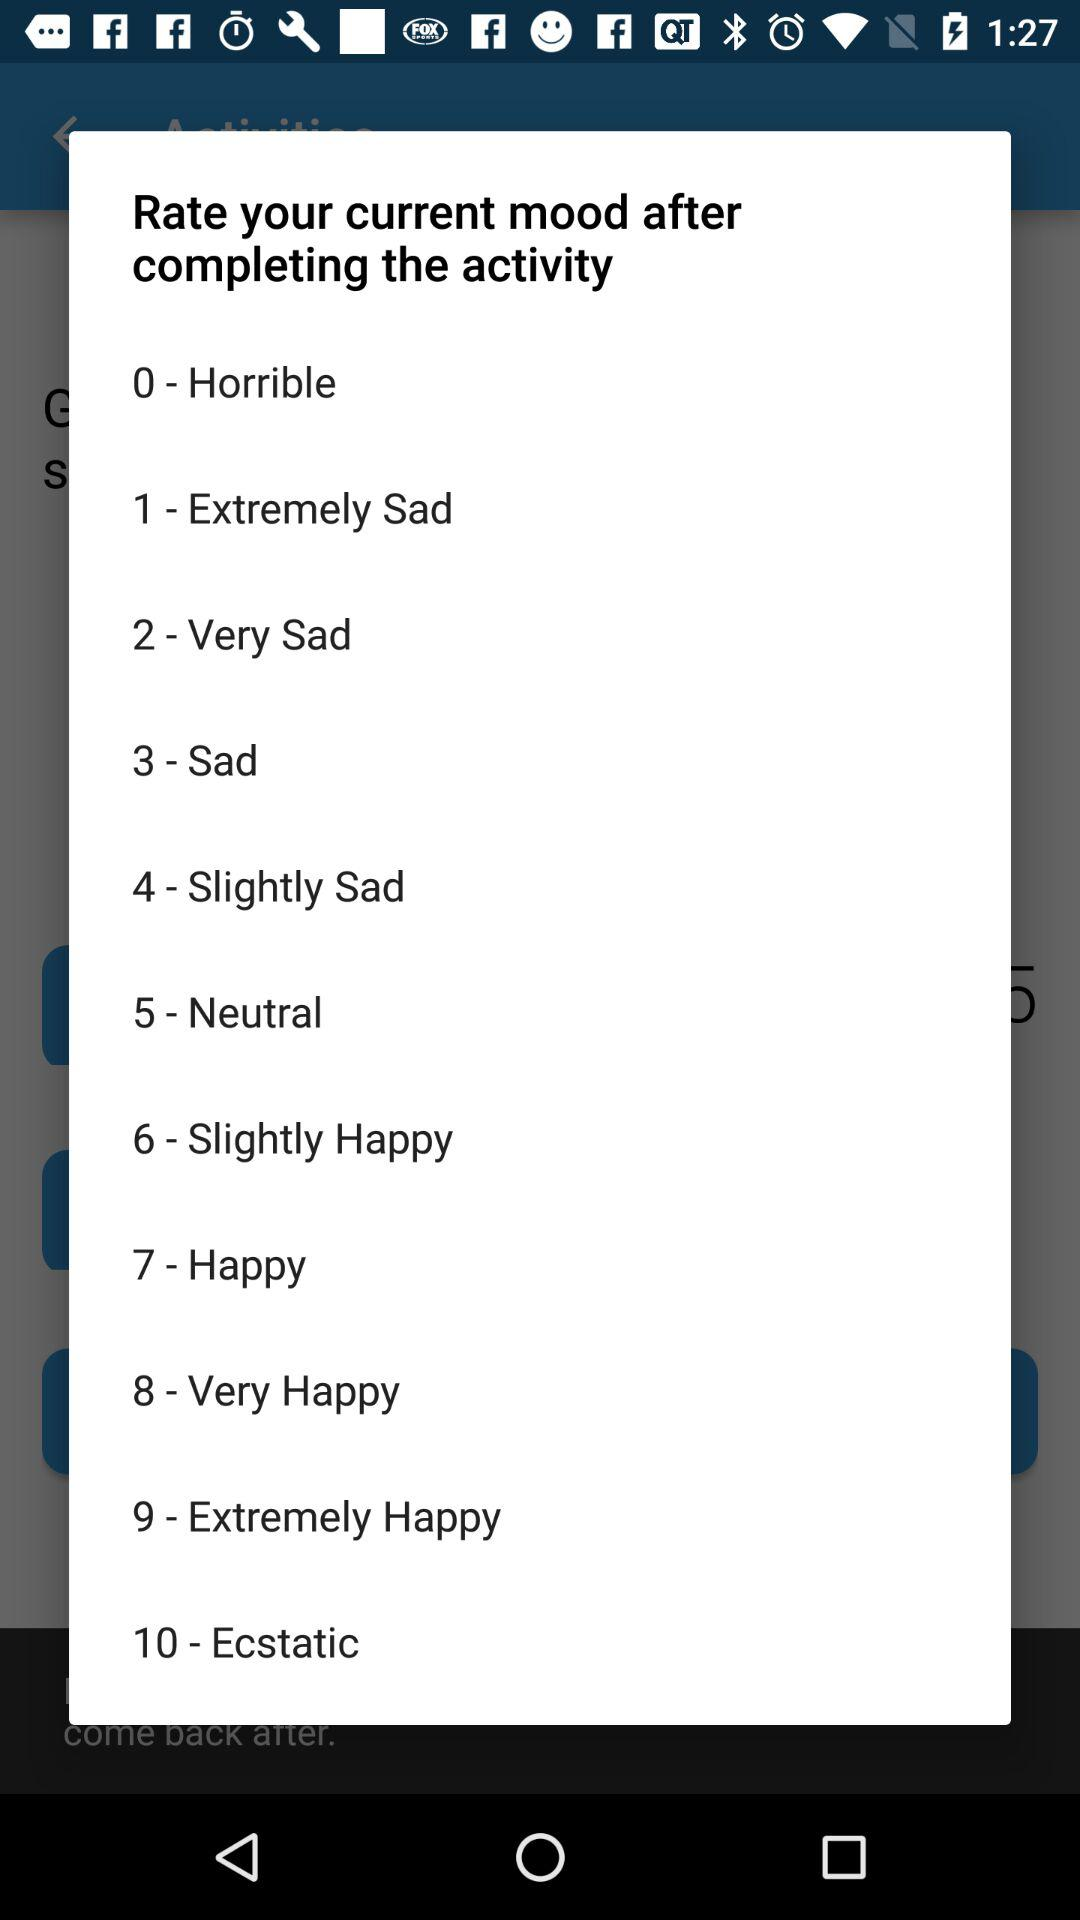What is Sad's star rating?
When the provided information is insufficient, respond with <no answer>. <no answer> 